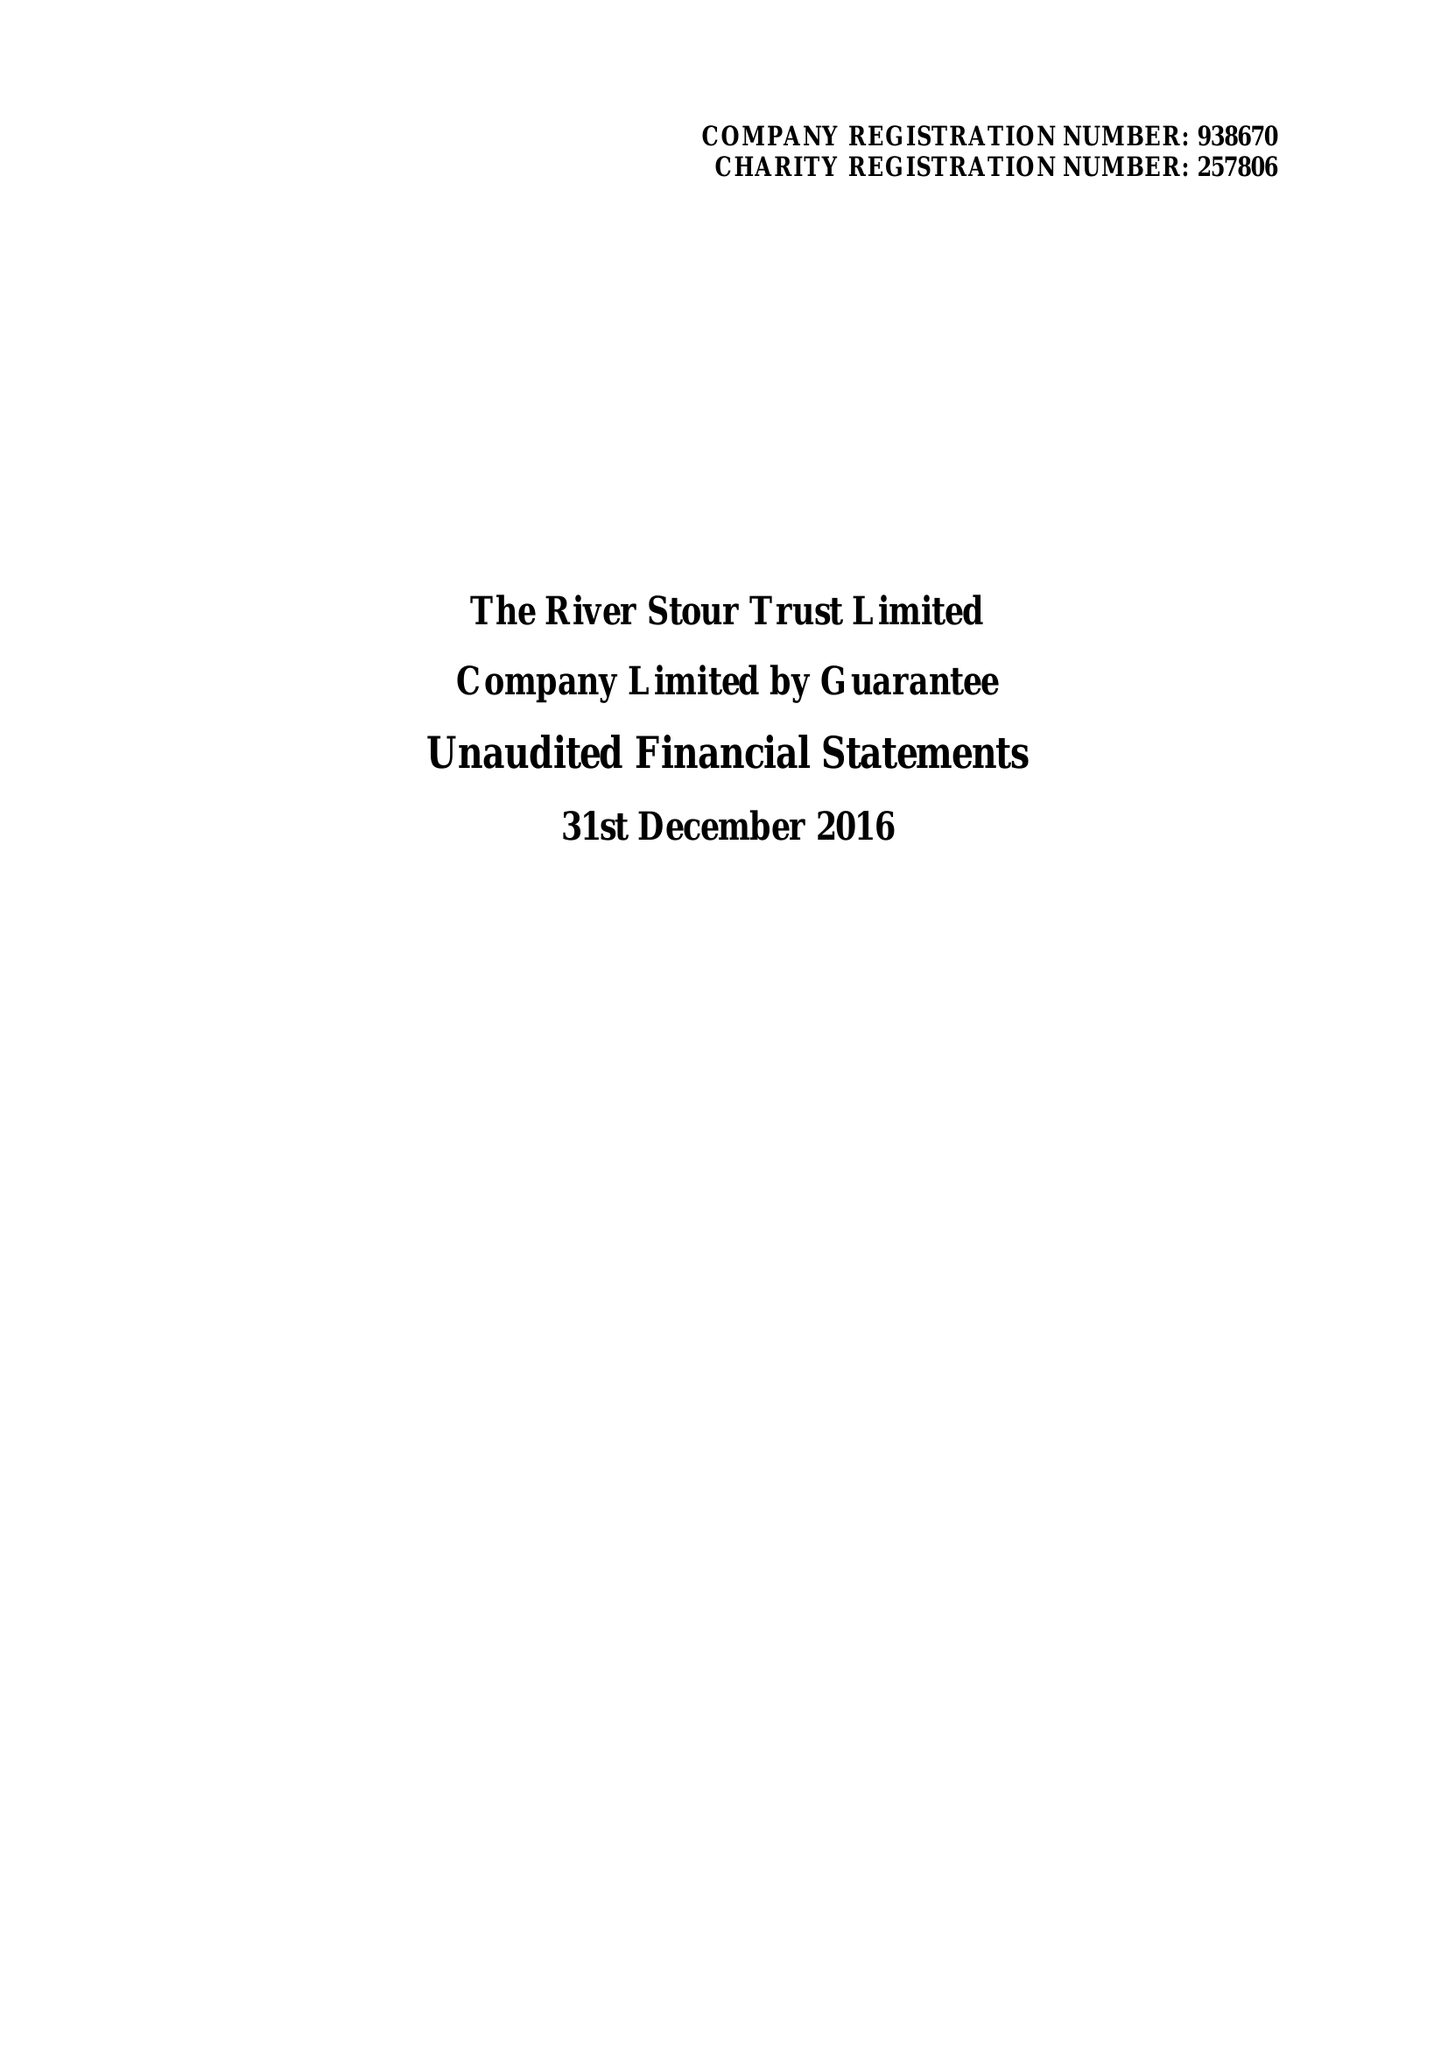What is the value for the charity_number?
Answer the question using a single word or phrase. 257806 